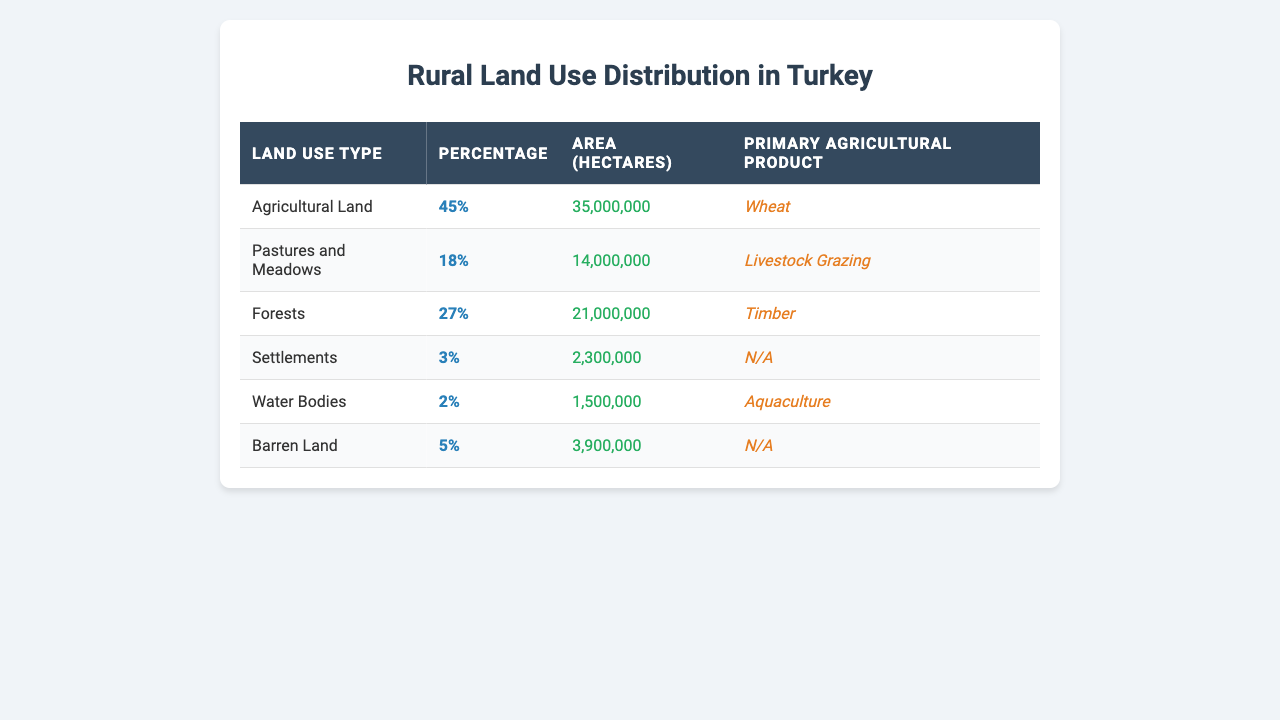What percentage of rural land is used for agricultural purposes? The table shows that agricultural land accounts for 45% of the total land use in rural areas.
Answer: 45% How many hectares are occupied by forests in rural Turkey? According to the table, forests occupy 21,000,000 hectares of land in rural Turkey.
Answer: 21,000,000 hectares What is the primary agricultural product associated with pastures and meadows? The table indicates that the primary agricultural product associated with pastures and meadows is livestock grazing.
Answer: Livestock Grazing Is the area used for settlements greater than the area used for water bodies? The area for settlements is 2,300,000 hectares, while the area for water bodies is 1,500,000 hectares. Since 2,300,000 > 1,500,000, the statement is true.
Answer: Yes What is the total area (in hectares) occupied by barren land and water bodies combined? The area for barren land is 3,900,000 hectares and for water bodies is 1,500,000 hectares. Summing them gives 3,900,000 + 1,500,000 = 5,400,000 hectares.
Answer: 5,400,000 hectares What percentage of the total land use in rural Turkey is represented by pastures and meadows and barren land combined? Pastures and meadows represent 18%, and barren land represents 5%. Adding them gives 18% + 5% = 23%.
Answer: 23% What type of land has the smallest area, and what is that area? Among all listed types, water bodies have the smallest area at 1,500,000 hectares.
Answer: Water Bodies, 1,500,000 hectares How many hectares are collectively used for agricultural land and pastures and meadows? Agricultural land has an area of 35,000,000 hectares, and pastures and meadows have 14,000,000 hectares. Adding them results in 35,000,000 + 14,000,000 = 49,000,000 hectares.
Answer: 49,000,000 hectares Are livestock grazing and timber the primary products of two different types of land use in rural Turkey? Livestock grazing is from pastures and meadows, and timber is from forests, confirming that they are from different types of land use.
Answer: Yes What is the average area of land for the types listed in the table (in hectares)? The areas listed are 35,000,000 (Agricultural), 14,000,000 (Pastures), 21,000,000 (Forests), 2,300,000 (Settlements), 1,500,000 (Water Bodies), and 3,900,000 (Barren Land). The total is 35,000,000 + 14,000,000 + 21,000,000 + 2,300,000 + 1,500,000 + 3,900,000 = 78,700,000 hectares. Dividing by 6 gives an average of 13,116,667 hectares.
Answer: 13,116,667 hectares 